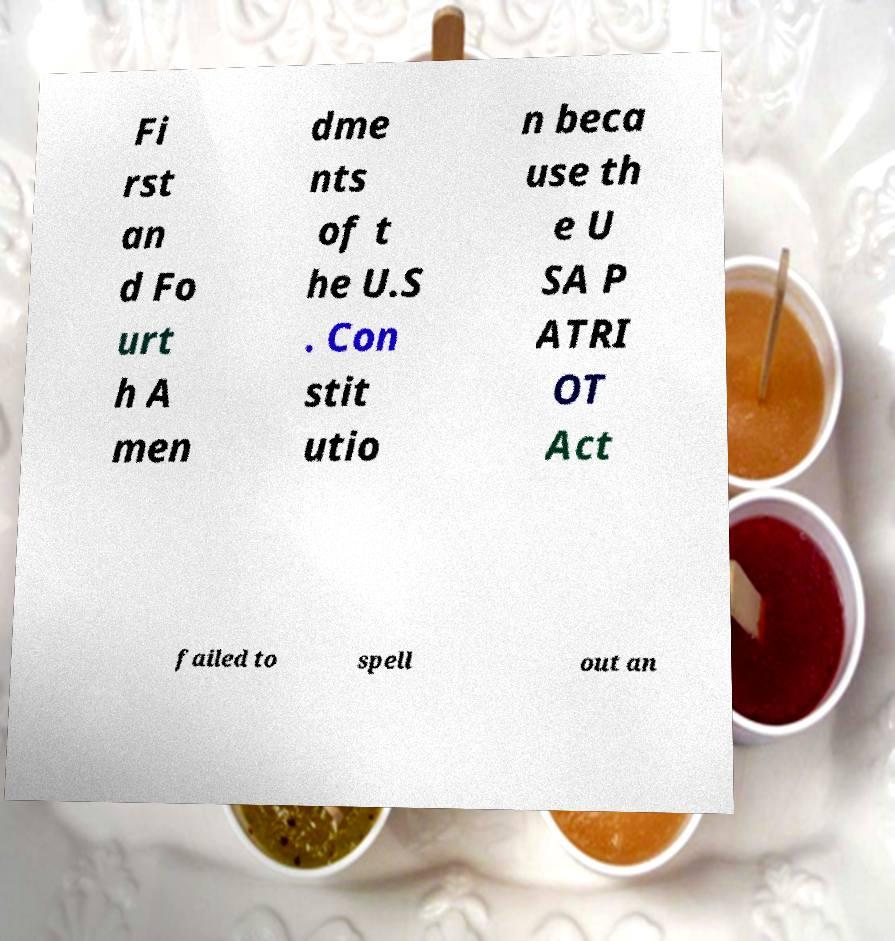Please identify and transcribe the text found in this image. Fi rst an d Fo urt h A men dme nts of t he U.S . Con stit utio n beca use th e U SA P ATRI OT Act failed to spell out an 